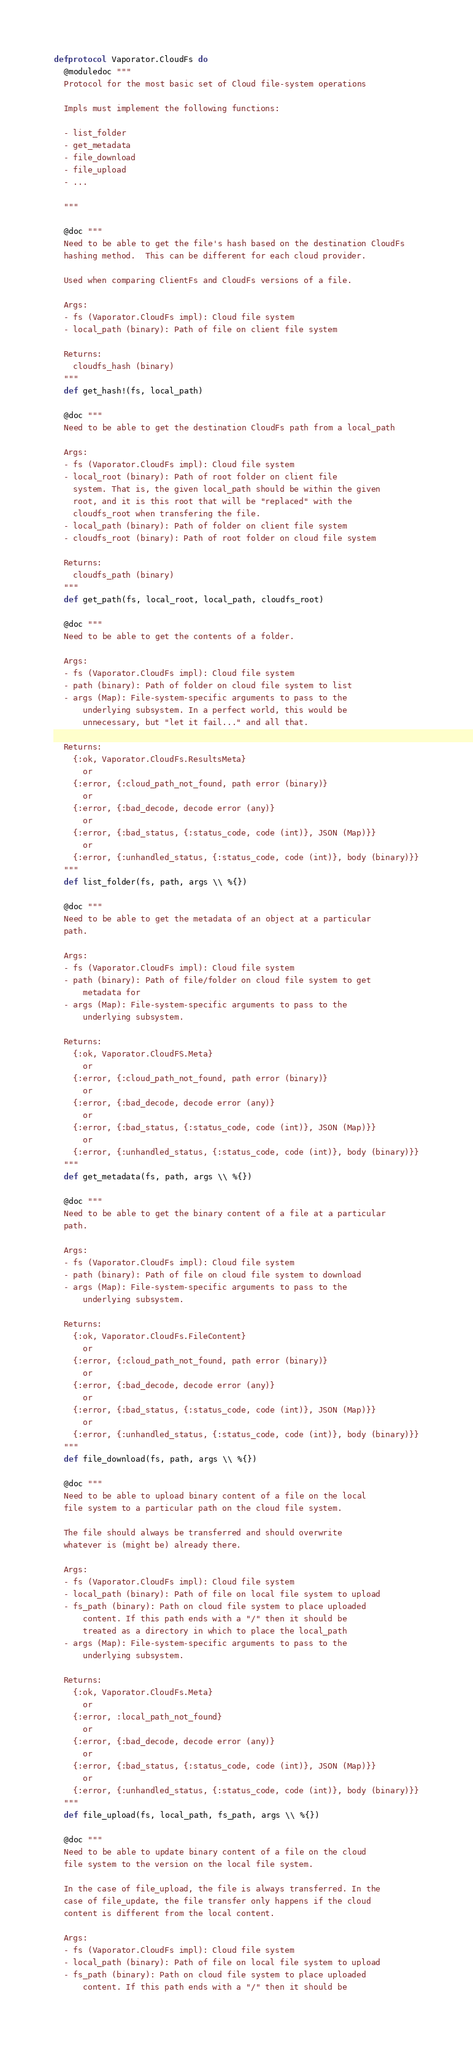Convert code to text. <code><loc_0><loc_0><loc_500><loc_500><_Elixir_>defprotocol Vaporator.CloudFs do
  @moduledoc """
  Protocol for the most basic set of Cloud file-system operations

  Impls must implement the following functions:

  - list_folder
  - get_metadata
  - file_download
  - file_upload
  - ...

  """

  @doc """
  Need to be able to get the file's hash based on the destination CloudFs
  hashing method.  This can be different for each cloud provider.

  Used when comparing ClientFs and CloudFs versions of a file.

  Args:
  - fs (Vaporator.CloudFs impl): Cloud file system
  - local_path (binary): Path of file on client file system

  Returns:
    cloudfs_hash (binary)
  """
  def get_hash!(fs, local_path)

  @doc """
  Need to be able to get the destination CloudFs path from a local_path

  Args:
  - fs (Vaporator.CloudFs impl): Cloud file system
  - local_root (binary): Path of root folder on client file
    system. That is, the given local_path should be within the given
    root, and it is this root that will be "replaced" with the
    cloudfs_root when transfering the file.
  - local_path (binary): Path of folder on client file system
  - cloudfs_root (binary): Path of root folder on cloud file system

  Returns:
    cloudfs_path (binary)
  """
  def get_path(fs, local_root, local_path, cloudfs_root)

  @doc """
  Need to be able to get the contents of a folder.

  Args:
  - fs (Vaporator.CloudFs impl): Cloud file system
  - path (binary): Path of folder on cloud file system to list
  - args (Map): File-system-specific arguments to pass to the
      underlying subsystem. In a perfect world, this would be
      unnecessary, but "let it fail..." and all that.

  Returns:
    {:ok, Vaporator.CloudFs.ResultsMeta}
      or
    {:error, {:cloud_path_not_found, path error (binary)}
      or 
    {:error, {:bad_decode, decode error (any)}
      or 
    {:error, {:bad_status, {:status_code, code (int)}, JSON (Map)}}
      or 
    {:error, {:unhandled_status, {:status_code, code (int)}, body (binary)}}
  """
  def list_folder(fs, path, args \\ %{})

  @doc """
  Need to be able to get the metadata of an object at a particular
  path.
  
  Args:
  - fs (Vaporator.CloudFs impl): Cloud file system
  - path (binary): Path of file/folder on cloud file system to get
      metadata for
  - args (Map): File-system-specific arguments to pass to the
      underlying subsystem. 
  
  Returns:
    {:ok, Vaporator.CloudFS.Meta}
      or
    {:error, {:cloud_path_not_found, path error (binary)}
      or 
    {:error, {:bad_decode, decode error (any)}
      or 
    {:error, {:bad_status, {:status_code, code (int)}, JSON (Map)}}
      or 
    {:error, {:unhandled_status, {:status_code, code (int)}, body (binary)}}
  """
  def get_metadata(fs, path, args \\ %{})

  @doc """
  Need to be able to get the binary content of a file at a particular
  path.
  
  Args:
  - fs (Vaporator.CloudFs impl): Cloud file system
  - path (binary): Path of file on cloud file system to download
  - args (Map): File-system-specific arguments to pass to the
      underlying subsystem. 
  
  Returns:
    {:ok, Vaporator.CloudFs.FileContent}
      or
    {:error, {:cloud_path_not_found, path error (binary)}
      or 
    {:error, {:bad_decode, decode error (any)}
      or 
    {:error, {:bad_status, {:status_code, code (int)}, JSON (Map)}}
      or 
    {:error, {:unhandled_status, {:status_code, code (int)}, body (binary)}}
  """
  def file_download(fs, path, args \\ %{})

  @doc """
  Need to be able to upload binary content of a file on the local
  file system to a particular path on the cloud file system.
  
  The file should always be transferred and should overwrite
  whatever is (might be) already there.
  
  Args:
  - fs (Vaporator.CloudFs impl): Cloud file system
  - local_path (binary): Path of file on local file system to upload
  - fs_path (binary): Path on cloud file system to place uploaded
      content. If this path ends with a "/" then it should be
      treated as a directory in which to place the local_path
  - args (Map): File-system-specific arguments to pass to the
      underlying subsystem. 
  
  Returns:
    {:ok, Vaporator.CloudFs.Meta}
      or
    {:error, :local_path_not_found}
      or
    {:error, {:bad_decode, decode error (any)}
      or 
    {:error, {:bad_status, {:status_code, code (int)}, JSON (Map)}}
      or 
    {:error, {:unhandled_status, {:status_code, code (int)}, body (binary)}}
  """
  def file_upload(fs, local_path, fs_path, args \\ %{})

  @doc """
  Need to be able to update binary content of a file on the cloud
  file system to the version on the local file system.
  
  In the case of file_upload, the file is always transferred. In the
  case of file_update, the file transfer only happens if the cloud
  content is different from the local content.
  
  Args:
  - fs (Vaporator.CloudFs impl): Cloud file system
  - local_path (binary): Path of file on local file system to upload
  - fs_path (binary): Path on cloud file system to place uploaded
      content. If this path ends with a "/" then it should be</code> 